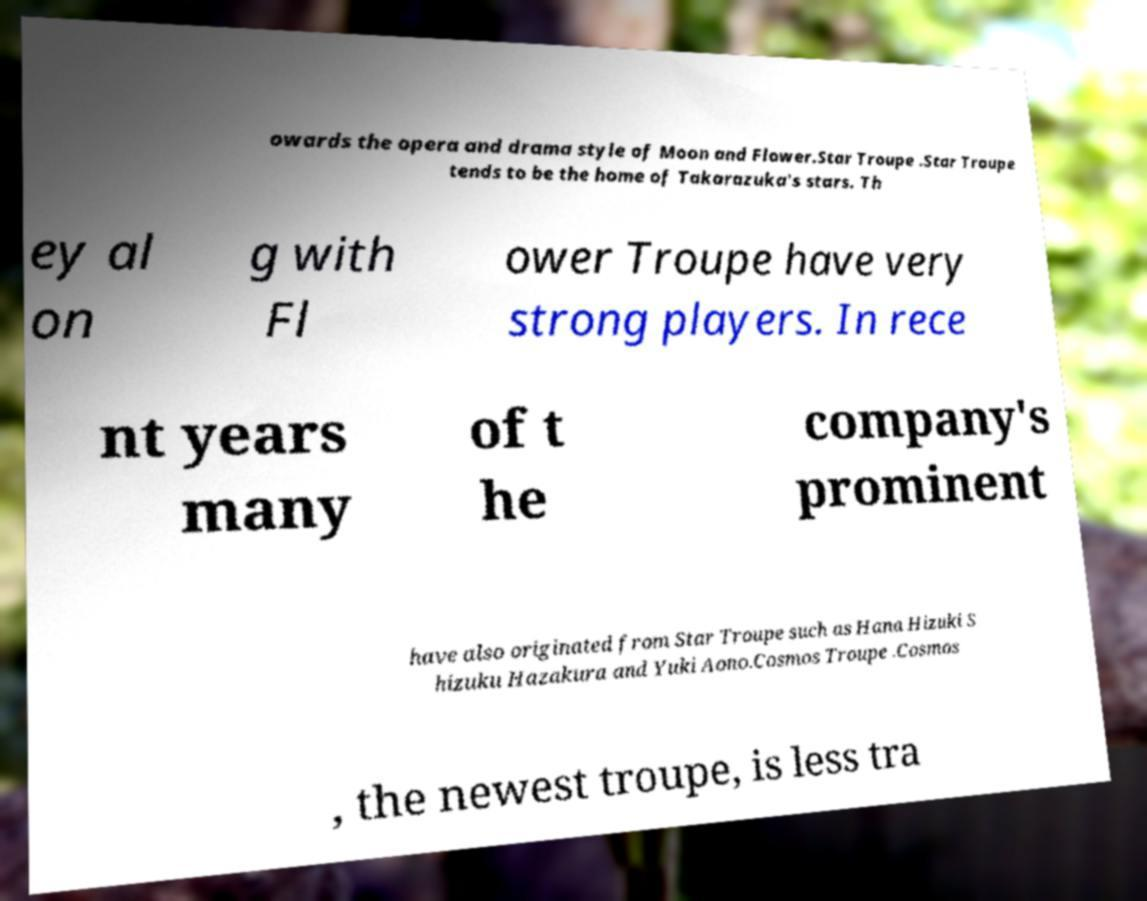Please read and relay the text visible in this image. What does it say? owards the opera and drama style of Moon and Flower.Star Troupe .Star Troupe tends to be the home of Takarazuka's stars. Th ey al on g with Fl ower Troupe have very strong players. In rece nt years many of t he company's prominent have also originated from Star Troupe such as Hana Hizuki S hizuku Hazakura and Yuki Aono.Cosmos Troupe .Cosmos , the newest troupe, is less tra 